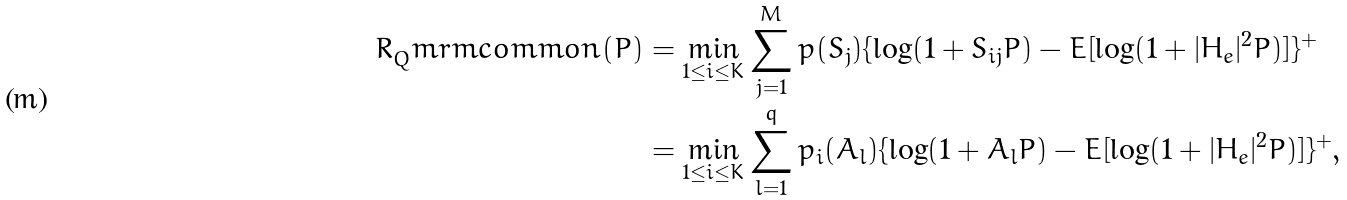Convert formula to latex. <formula><loc_0><loc_0><loc_500><loc_500>R _ { Q } ^ { \ } m r m { c o m m o n } ( P ) & = \min _ { 1 \leq i \leq K } \sum _ { j = 1 } ^ { M } p ( S _ { j } ) \{ \log ( 1 + S _ { i j } P ) - E [ \log ( 1 + | H _ { e } | ^ { 2 } P ) ] \} ^ { + } \\ & = \min _ { 1 \leq i \leq K } \sum _ { l = 1 } ^ { q } p _ { i } ( A _ { l } ) \{ \log ( 1 + A _ { l } P ) - E [ \log ( 1 + | H _ { e } | ^ { 2 } P ) ] \} ^ { + } ,</formula> 